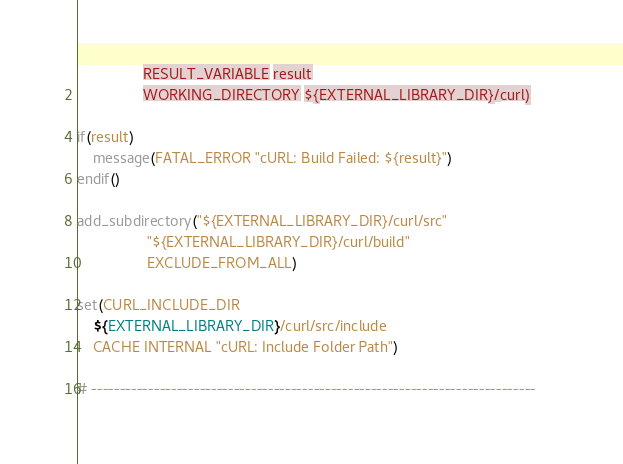<code> <loc_0><loc_0><loc_500><loc_500><_CMake_>                RESULT_VARIABLE result
                WORKING_DIRECTORY ${EXTERNAL_LIBRARY_DIR}/curl)

if(result)
    message(FATAL_ERROR "cURL: Build Failed: ${result}")
endif()

add_subdirectory("${EXTERNAL_LIBRARY_DIR}/curl/src"
                 "${EXTERNAL_LIBRARY_DIR}/curl/build"
                 EXCLUDE_FROM_ALL)

set(CURL_INCLUDE_DIR
    ${EXTERNAL_LIBRARY_DIR}/curl/src/include
    CACHE INTERNAL "cURL: Include Folder Path")

# ------------------------------------------------------------------------------
</code> 